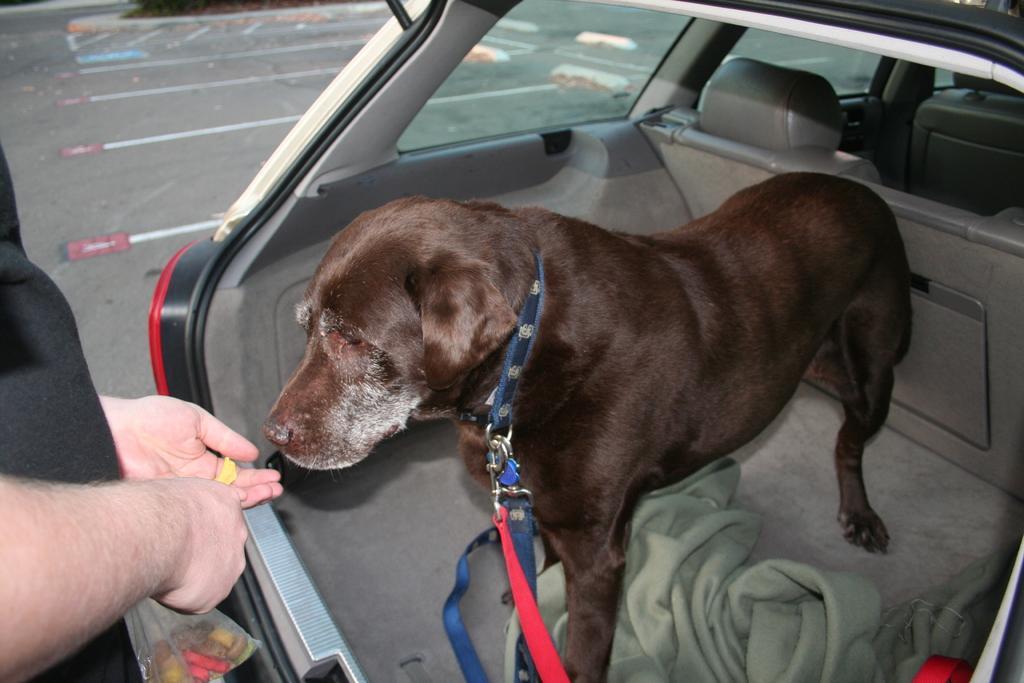Can you describe this image briefly? This picture is clicked outside. On the right there is a dog standing in the car. On the left there is a person standing and holding an object. In the background we can see the road. 